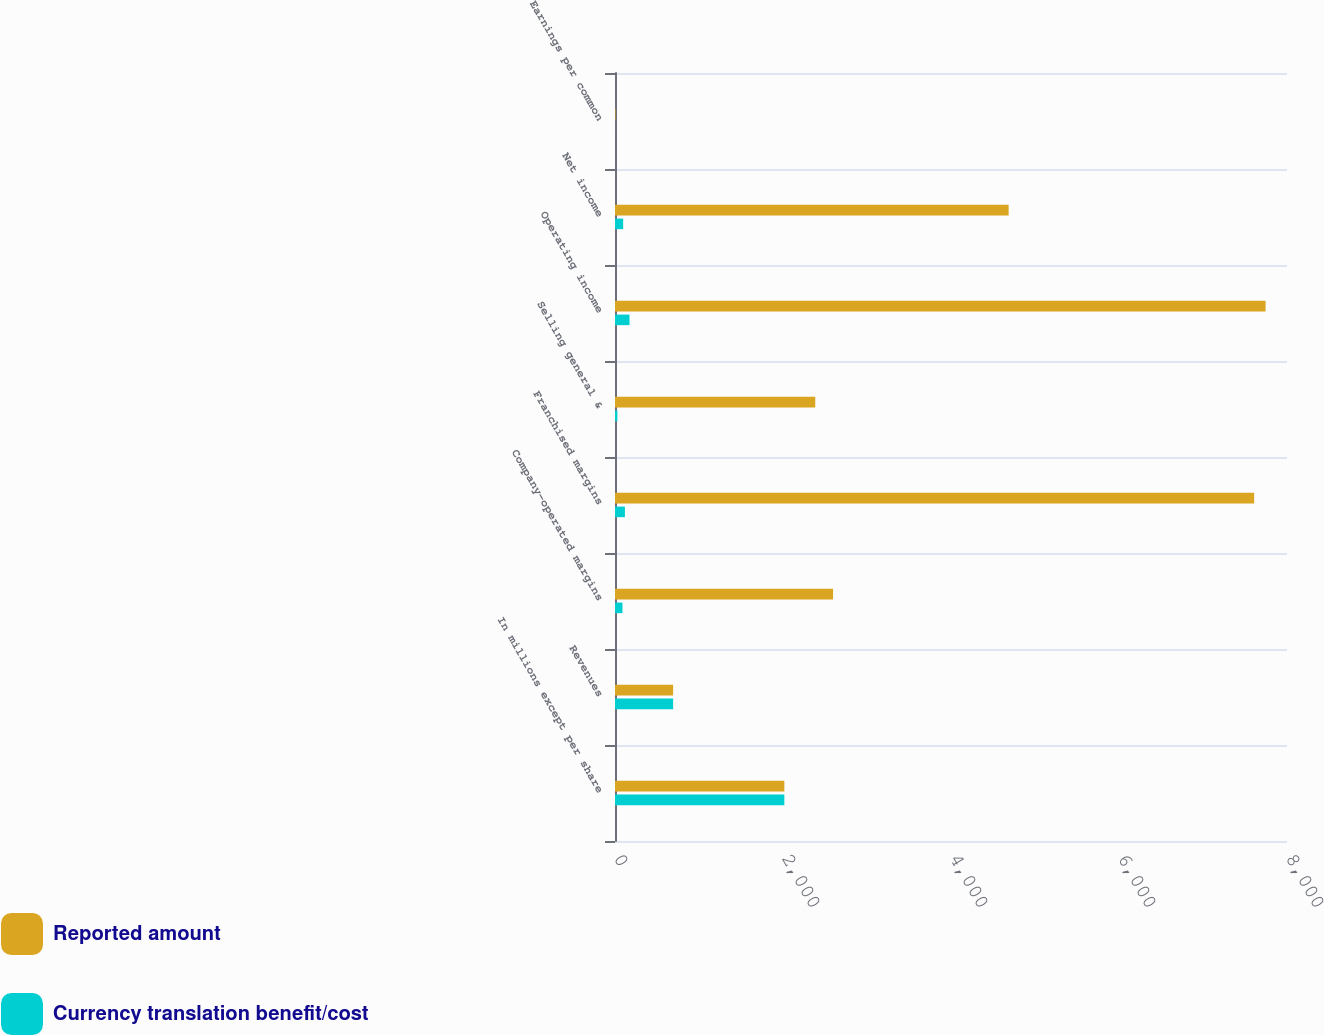<chart> <loc_0><loc_0><loc_500><loc_500><stacked_bar_chart><ecel><fcel>In millions except per share<fcel>Revenues<fcel>Company-operated margins<fcel>Franchised margins<fcel>Selling general &<fcel>Operating income<fcel>Net income<fcel>Earnings per common<nl><fcel>Reported amount<fcel>2016<fcel>692<fcel>2596<fcel>7609<fcel>2384<fcel>7745<fcel>4686<fcel>5.44<nl><fcel>Currency translation benefit/cost<fcel>2016<fcel>692<fcel>89<fcel>118<fcel>28<fcel>173<fcel>97<fcel>0.11<nl></chart> 